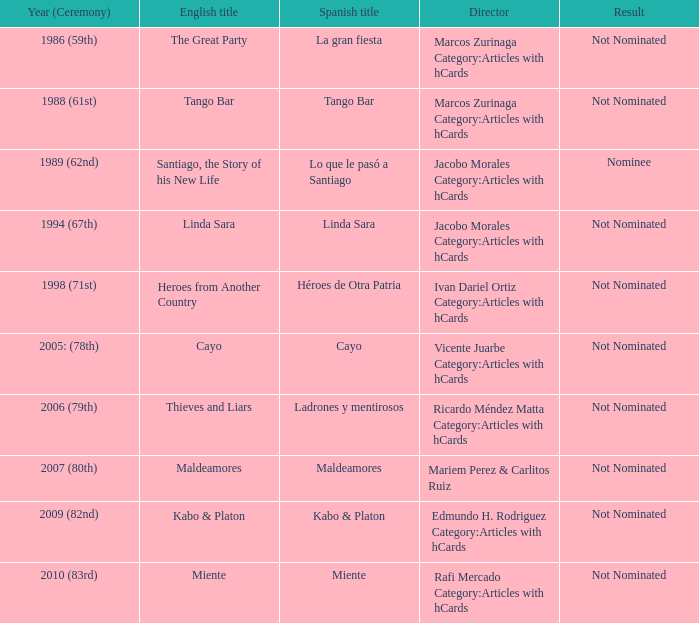Who was the director for Tango Bar? Marcos Zurinaga Category:Articles with hCards. 